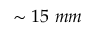<formula> <loc_0><loc_0><loc_500><loc_500>\sim 1 5 m m</formula> 